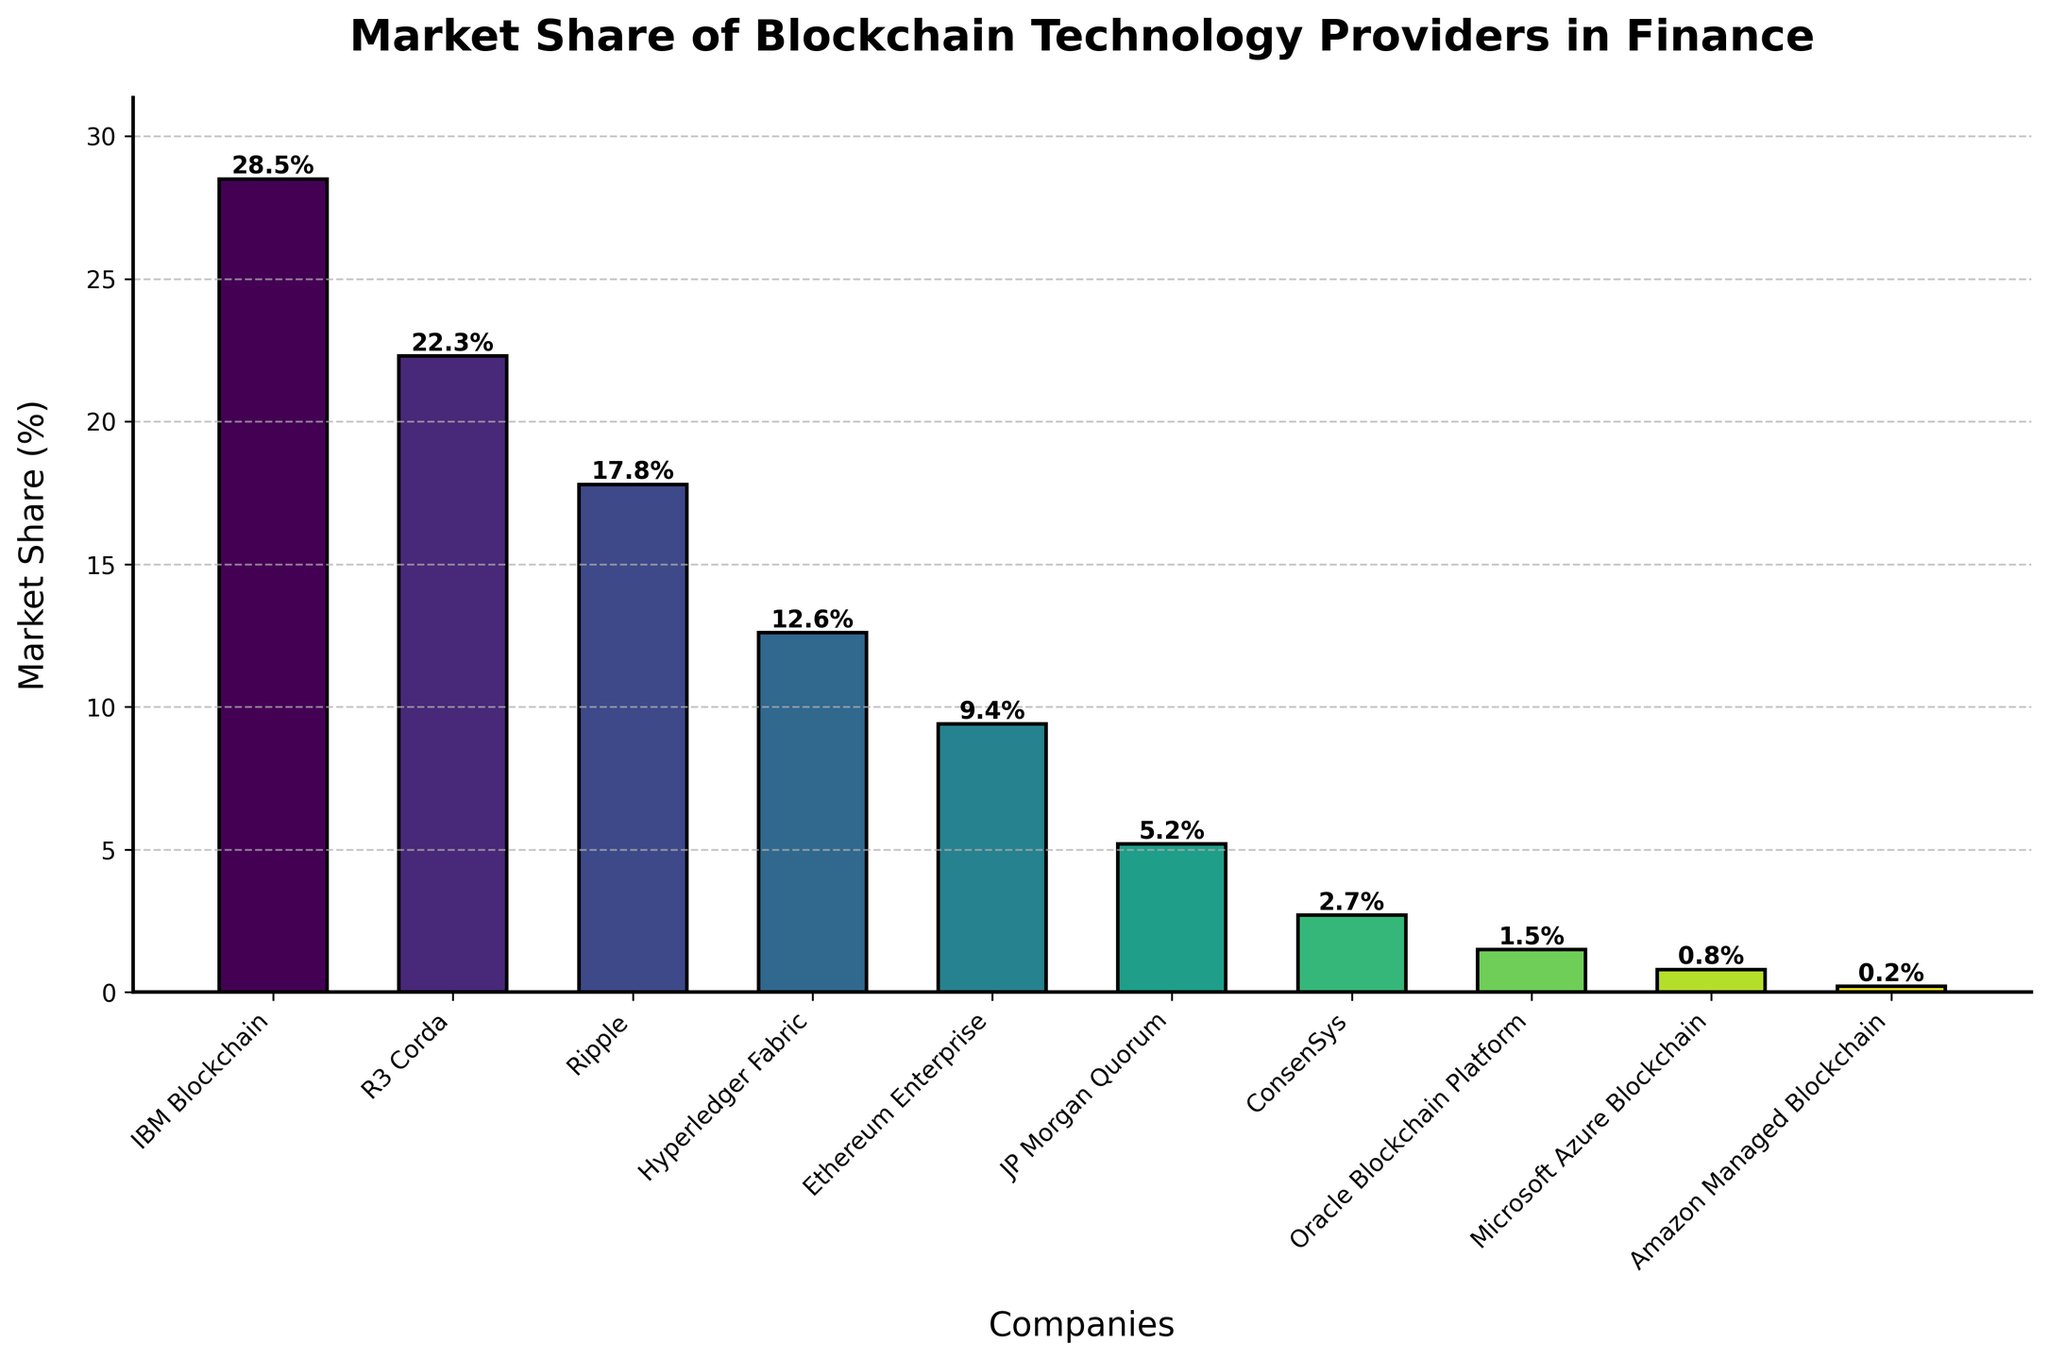What is the market share of IBM Blockchain? To determine the market share of IBM Blockchain, look at the height of the bar labeled "IBM Blockchain" on the x-axis. The numerical value provided at the top of the bar indicates its market share percentage.
Answer: 28.5% Which company has the lowest market share and what is it? To identify the company with the lowest market share, observe the bar with the smallest height. The label on the x-axis below this bar corresponds to the company, and the market share percentage is indicated at the top of the bar.
Answer: Amazon Managed Blockchain, 0.2% What is the total market share of R3 Corda and Ripple combined? To find the total market share of R3 Corda and Ripple, locate the bars for each company and note their market share percentages. Sum these percentages: 22.3% (R3 Corda) + 17.8% (Ripple).
Answer: 40.1% How much higher is the market share of Hyperledger Fabric than Microsoft Azure Blockchain? First, find the market shares of Hyperledger Fabric and Microsoft Azure Blockchain by locating their bars and noting the percentages: Hyperledger Fabric (12.6%) and Microsoft Azure Blockchain (0.8%). Subtract the second percentage from the first: 12.6% - 0.8%.
Answer: 11.8% Which company has a market share closest to 10% and what is the percentage? Examine the bars to find the one with a market share percentage nearest to 10%. The bar for Ethereum Enterprise shows a market share of 9.4%, which is the closest to 10%.
Answer: Ethereum Enterprise, 9.4% Which companies have a market share above 20%? Identify the bars with heights representing market shares exceeding 20%. The companies corresponding to these bars are IBM Blockchain (28.5%) and R3 Corda (22.3%).
Answer: IBM Blockchain and R3 Corda What is the average market share of the bottom three companies? Find the market shares for the bottom three companies by locating the bars with the smallest heights: these are Amazon Managed Blockchain (0.2%), Microsoft Azure Blockchain (0.8%), and Oracle Blockchain Platform (1.5%). Calculate their average by summing the percentages and dividing by 3: (0.2% + 0.8% + 1.5%) / 3.
Answer: 0.83% What is the difference in market share between Ripple and JP Morgan Quorum? To determine the difference in market share between Ripple and JP Morgan Quorum, locate their bars and note the market share percentages: Ripple (17.8%) and JP Morgan Quorum (5.2%). Subtract the second percentage from the first: 17.8% - 5.2%.
Answer: 12.6% What is the cumulative market share of the top five companies? Identify the top five companies by the height of their bars, which correspond to the highest market shares: IBM Blockchain (28.5%), R3 Corda (22.3%), Ripple (17.8%), Hyperledger Fabric (12.6%), and Ethereum Enterprise (9.4%). Sum these percentages: 28.5% + 22.3% + 17.8% + 12.6% + 9.4%.
Answer: 90.6% How many companies have a market share less than 5%? Determine the companies with market shares below 5% by examining the bars with heights representing values less than 5%. The companies are JP Morgan Quorum (5.2%) [slightly above 5%, so not included], ConsenSys (2.7%), Oracle Blockchain Platform (1.5%), Microsoft Azure Blockchain (0.8%), and Amazon Managed Blockchain (0.2%). Count these companies.
Answer: 4 